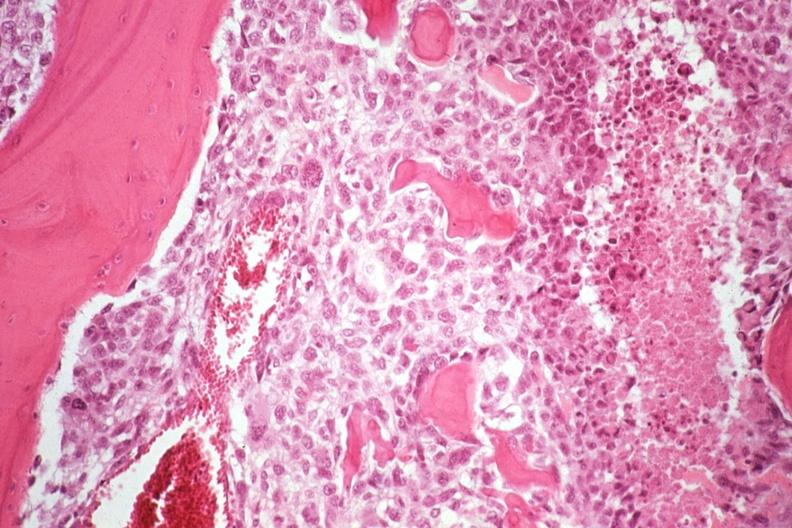s joints present?
Answer the question using a single word or phrase. Yes 